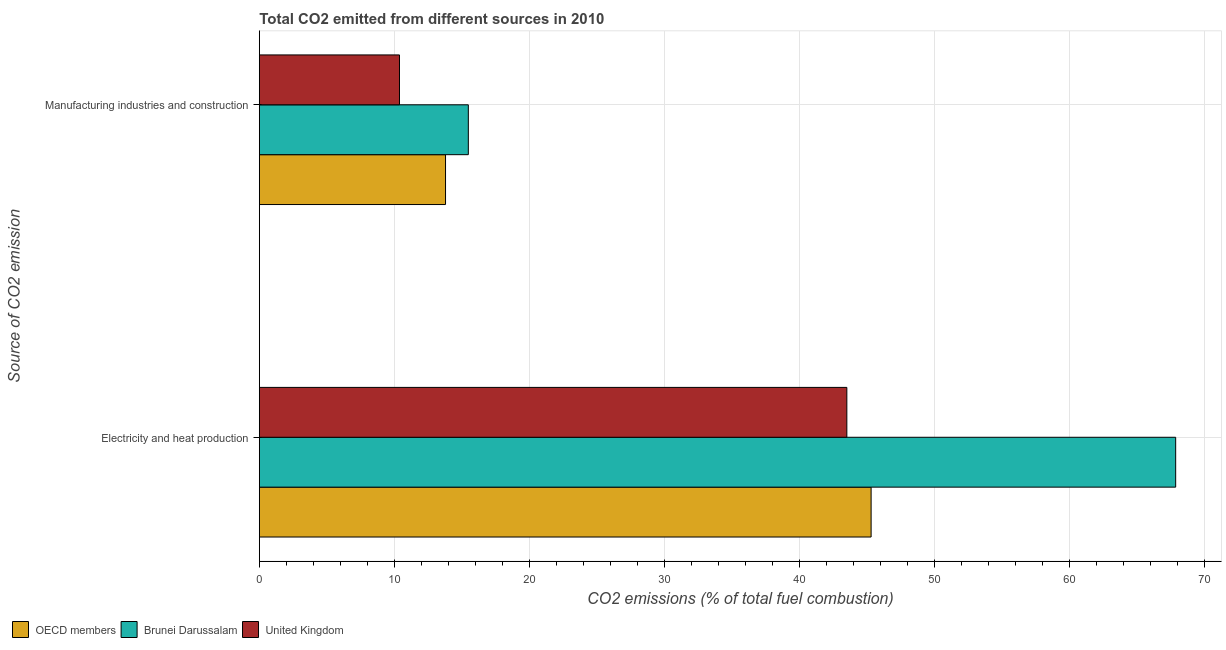How many groups of bars are there?
Provide a short and direct response. 2. What is the label of the 2nd group of bars from the top?
Offer a terse response. Electricity and heat production. What is the co2 emissions due to electricity and heat production in Brunei Darussalam?
Keep it short and to the point. 67.86. Across all countries, what is the maximum co2 emissions due to manufacturing industries?
Offer a terse response. 15.48. Across all countries, what is the minimum co2 emissions due to electricity and heat production?
Your answer should be very brief. 43.51. In which country was the co2 emissions due to manufacturing industries maximum?
Offer a very short reply. Brunei Darussalam. What is the total co2 emissions due to manufacturing industries in the graph?
Provide a succinct answer. 39.64. What is the difference between the co2 emissions due to electricity and heat production in United Kingdom and that in OECD members?
Your answer should be compact. -1.8. What is the difference between the co2 emissions due to electricity and heat production in OECD members and the co2 emissions due to manufacturing industries in Brunei Darussalam?
Your answer should be compact. 29.83. What is the average co2 emissions due to manufacturing industries per country?
Make the answer very short. 13.21. What is the difference between the co2 emissions due to electricity and heat production and co2 emissions due to manufacturing industries in Brunei Darussalam?
Give a very brief answer. 52.38. In how many countries, is the co2 emissions due to manufacturing industries greater than 62 %?
Your answer should be very brief. 0. What is the ratio of the co2 emissions due to electricity and heat production in Brunei Darussalam to that in OECD members?
Provide a short and direct response. 1.5. Is the co2 emissions due to manufacturing industries in OECD members less than that in Brunei Darussalam?
Provide a short and direct response. Yes. In how many countries, is the co2 emissions due to electricity and heat production greater than the average co2 emissions due to electricity and heat production taken over all countries?
Make the answer very short. 1. What does the 1st bar from the top in Electricity and heat production represents?
Make the answer very short. United Kingdom. What does the 1st bar from the bottom in Electricity and heat production represents?
Offer a terse response. OECD members. Are all the bars in the graph horizontal?
Ensure brevity in your answer.  Yes. How many countries are there in the graph?
Keep it short and to the point. 3. What is the difference between two consecutive major ticks on the X-axis?
Offer a terse response. 10. Where does the legend appear in the graph?
Your answer should be very brief. Bottom left. How many legend labels are there?
Offer a very short reply. 3. What is the title of the graph?
Your response must be concise. Total CO2 emitted from different sources in 2010. What is the label or title of the X-axis?
Provide a succinct answer. CO2 emissions (% of total fuel combustion). What is the label or title of the Y-axis?
Keep it short and to the point. Source of CO2 emission. What is the CO2 emissions (% of total fuel combustion) in OECD members in Electricity and heat production?
Keep it short and to the point. 45.3. What is the CO2 emissions (% of total fuel combustion) in Brunei Darussalam in Electricity and heat production?
Give a very brief answer. 67.86. What is the CO2 emissions (% of total fuel combustion) in United Kingdom in Electricity and heat production?
Provide a succinct answer. 43.51. What is the CO2 emissions (% of total fuel combustion) in OECD members in Manufacturing industries and construction?
Your answer should be very brief. 13.79. What is the CO2 emissions (% of total fuel combustion) of Brunei Darussalam in Manufacturing industries and construction?
Your response must be concise. 15.48. What is the CO2 emissions (% of total fuel combustion) of United Kingdom in Manufacturing industries and construction?
Make the answer very short. 10.38. Across all Source of CO2 emission, what is the maximum CO2 emissions (% of total fuel combustion) in OECD members?
Keep it short and to the point. 45.3. Across all Source of CO2 emission, what is the maximum CO2 emissions (% of total fuel combustion) of Brunei Darussalam?
Keep it short and to the point. 67.86. Across all Source of CO2 emission, what is the maximum CO2 emissions (% of total fuel combustion) of United Kingdom?
Your response must be concise. 43.51. Across all Source of CO2 emission, what is the minimum CO2 emissions (% of total fuel combustion) of OECD members?
Your answer should be very brief. 13.79. Across all Source of CO2 emission, what is the minimum CO2 emissions (% of total fuel combustion) in Brunei Darussalam?
Offer a terse response. 15.48. Across all Source of CO2 emission, what is the minimum CO2 emissions (% of total fuel combustion) in United Kingdom?
Offer a very short reply. 10.38. What is the total CO2 emissions (% of total fuel combustion) of OECD members in the graph?
Offer a very short reply. 59.09. What is the total CO2 emissions (% of total fuel combustion) in Brunei Darussalam in the graph?
Offer a very short reply. 83.33. What is the total CO2 emissions (% of total fuel combustion) in United Kingdom in the graph?
Offer a terse response. 53.88. What is the difference between the CO2 emissions (% of total fuel combustion) of OECD members in Electricity and heat production and that in Manufacturing industries and construction?
Ensure brevity in your answer.  31.52. What is the difference between the CO2 emissions (% of total fuel combustion) of Brunei Darussalam in Electricity and heat production and that in Manufacturing industries and construction?
Your answer should be very brief. 52.38. What is the difference between the CO2 emissions (% of total fuel combustion) of United Kingdom in Electricity and heat production and that in Manufacturing industries and construction?
Provide a succinct answer. 33.13. What is the difference between the CO2 emissions (% of total fuel combustion) in OECD members in Electricity and heat production and the CO2 emissions (% of total fuel combustion) in Brunei Darussalam in Manufacturing industries and construction?
Provide a short and direct response. 29.83. What is the difference between the CO2 emissions (% of total fuel combustion) of OECD members in Electricity and heat production and the CO2 emissions (% of total fuel combustion) of United Kingdom in Manufacturing industries and construction?
Your answer should be very brief. 34.93. What is the difference between the CO2 emissions (% of total fuel combustion) in Brunei Darussalam in Electricity and heat production and the CO2 emissions (% of total fuel combustion) in United Kingdom in Manufacturing industries and construction?
Your answer should be compact. 57.48. What is the average CO2 emissions (% of total fuel combustion) in OECD members per Source of CO2 emission?
Provide a short and direct response. 29.55. What is the average CO2 emissions (% of total fuel combustion) in Brunei Darussalam per Source of CO2 emission?
Your answer should be compact. 41.67. What is the average CO2 emissions (% of total fuel combustion) in United Kingdom per Source of CO2 emission?
Provide a succinct answer. 26.94. What is the difference between the CO2 emissions (% of total fuel combustion) of OECD members and CO2 emissions (% of total fuel combustion) of Brunei Darussalam in Electricity and heat production?
Provide a succinct answer. -22.55. What is the difference between the CO2 emissions (% of total fuel combustion) of OECD members and CO2 emissions (% of total fuel combustion) of United Kingdom in Electricity and heat production?
Provide a short and direct response. 1.8. What is the difference between the CO2 emissions (% of total fuel combustion) in Brunei Darussalam and CO2 emissions (% of total fuel combustion) in United Kingdom in Electricity and heat production?
Your answer should be very brief. 24.35. What is the difference between the CO2 emissions (% of total fuel combustion) of OECD members and CO2 emissions (% of total fuel combustion) of Brunei Darussalam in Manufacturing industries and construction?
Your answer should be compact. -1.69. What is the difference between the CO2 emissions (% of total fuel combustion) of OECD members and CO2 emissions (% of total fuel combustion) of United Kingdom in Manufacturing industries and construction?
Make the answer very short. 3.41. What is the difference between the CO2 emissions (% of total fuel combustion) of Brunei Darussalam and CO2 emissions (% of total fuel combustion) of United Kingdom in Manufacturing industries and construction?
Offer a terse response. 5.1. What is the ratio of the CO2 emissions (% of total fuel combustion) in OECD members in Electricity and heat production to that in Manufacturing industries and construction?
Give a very brief answer. 3.29. What is the ratio of the CO2 emissions (% of total fuel combustion) in Brunei Darussalam in Electricity and heat production to that in Manufacturing industries and construction?
Ensure brevity in your answer.  4.38. What is the ratio of the CO2 emissions (% of total fuel combustion) in United Kingdom in Electricity and heat production to that in Manufacturing industries and construction?
Offer a very short reply. 4.19. What is the difference between the highest and the second highest CO2 emissions (% of total fuel combustion) of OECD members?
Provide a succinct answer. 31.52. What is the difference between the highest and the second highest CO2 emissions (% of total fuel combustion) in Brunei Darussalam?
Give a very brief answer. 52.38. What is the difference between the highest and the second highest CO2 emissions (% of total fuel combustion) in United Kingdom?
Keep it short and to the point. 33.13. What is the difference between the highest and the lowest CO2 emissions (% of total fuel combustion) in OECD members?
Your response must be concise. 31.52. What is the difference between the highest and the lowest CO2 emissions (% of total fuel combustion) of Brunei Darussalam?
Provide a succinct answer. 52.38. What is the difference between the highest and the lowest CO2 emissions (% of total fuel combustion) in United Kingdom?
Provide a short and direct response. 33.13. 